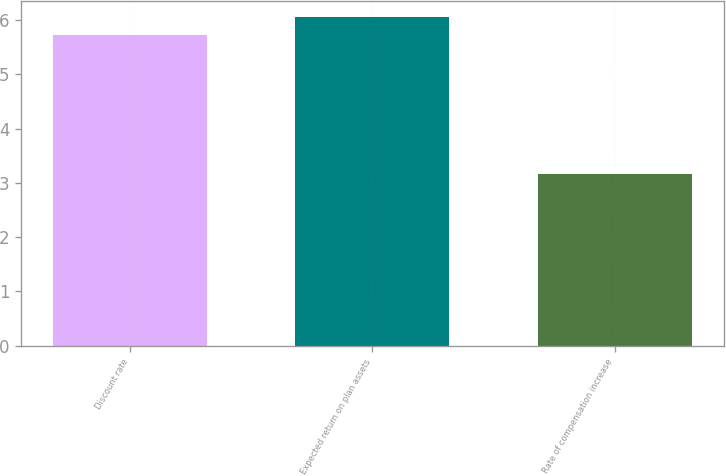<chart> <loc_0><loc_0><loc_500><loc_500><bar_chart><fcel>Discount rate<fcel>Expected return on plan assets<fcel>Rate of compensation increase<nl><fcel>5.73<fcel>6.05<fcel>3.17<nl></chart> 